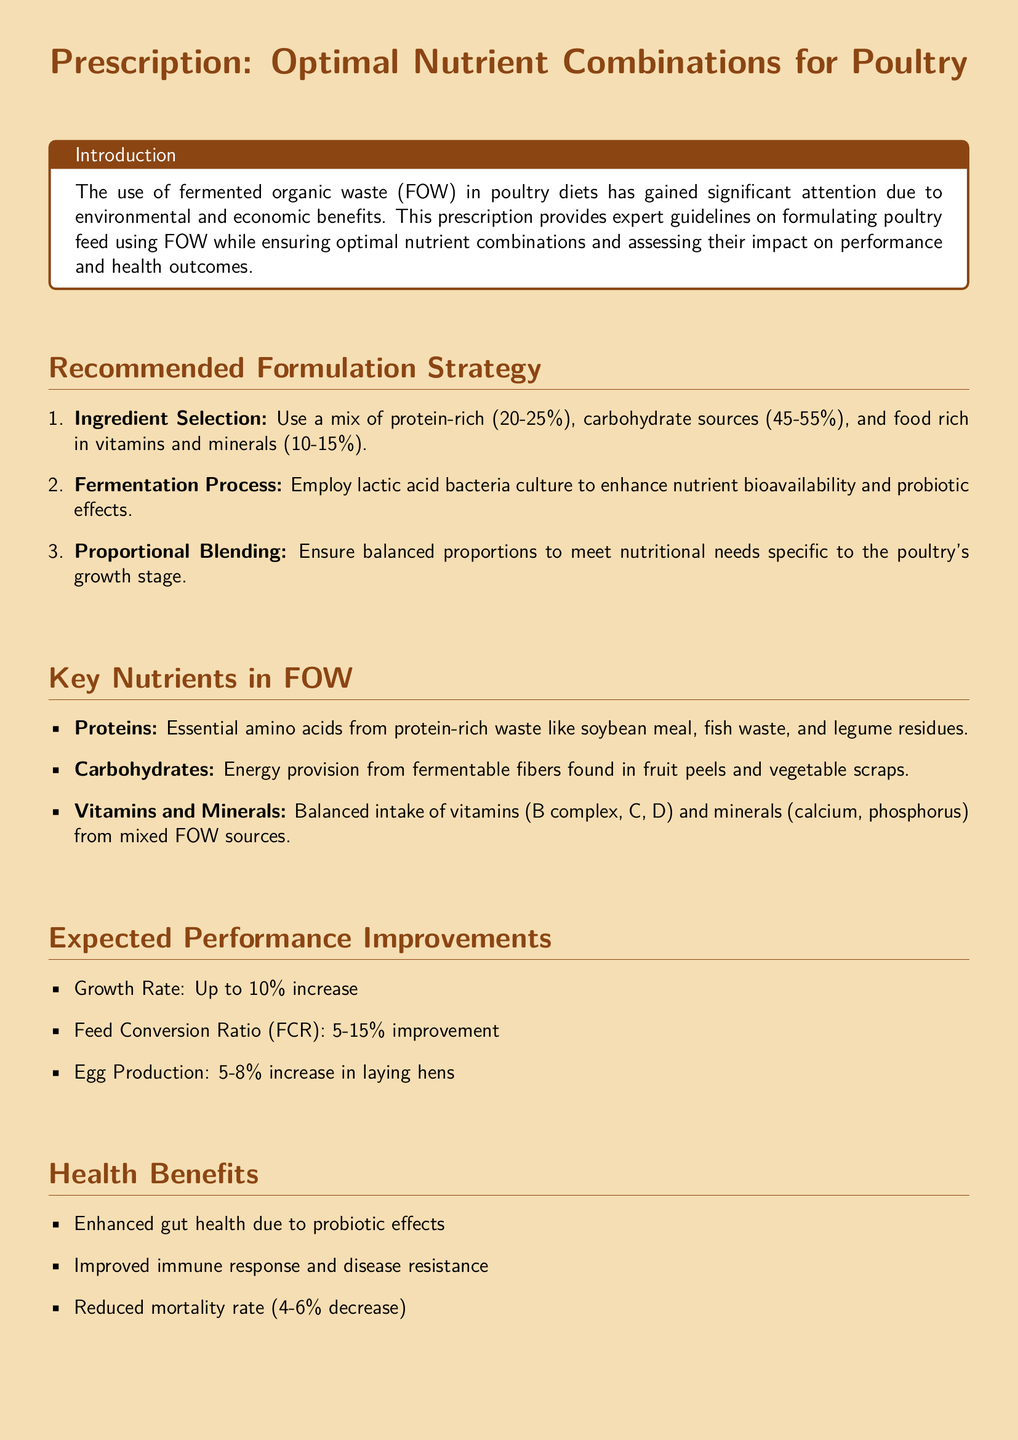What is the recommended protein content in the poultry diet using fermented organic waste? The recommended protein content is between 20-25%.
Answer: 20-25% What fermentation process is suggested for enhancing nutrient bioavailability? The document recommends employing lactic acid bacteria culture.
Answer: Lactic acid bacteria culture What are the expected improvements in feed conversion ratio (FCR)? The expected improvement in FCR is 5-15%.
Answer: 5-15% Which types of waste are recommended for protein sources? Protein-rich waste sources include soybean meal, fish waste, and legume residues.
Answer: Soybean meal, fish waste, legume residues How much can growth rate increase with the recommended diet? The growth rate can increase by up to 10%.
Answer: Up to 10% What health benefit is associated with the use of fermented organic waste? An enhanced immune response and disease resistance is a health benefit.
Answer: Enhanced immune response and disease resistance What percentage reduction in feed costs was reported in a case study? The case study highlighted a 5% reduction in feed costs.
Answer: 5% What vitamins are specifically mentioned as important in the feed formulation? The vitamins mentioned include B complex, C, and D.
Answer: B complex, C, D What is the total expected increase in egg production for laying hens? The total expected increase in egg production is 5-8%.
Answer: 5-8% 